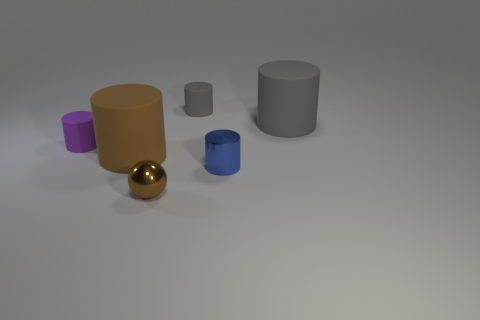What could be the purpose of arranging these objects like this? This looks like a setup that could be used for either educational or display purposes. It could be part of a lesson on geometry and color theory, illustrating how different shapes interact with light and shadows. Alternatively, it could serve as a simple visual composition exercise in photography or 3D modeling.  Does anything in the image suggest that it is part of a larger context? Nothing in the image directly suggests that it's part of a larger context. However, the neat and isolated arrangement of objects against a nondescript background may imply that it's a controlled setting, possibly designed for a specific purpose such as a study on object rendering or an artistic display. 